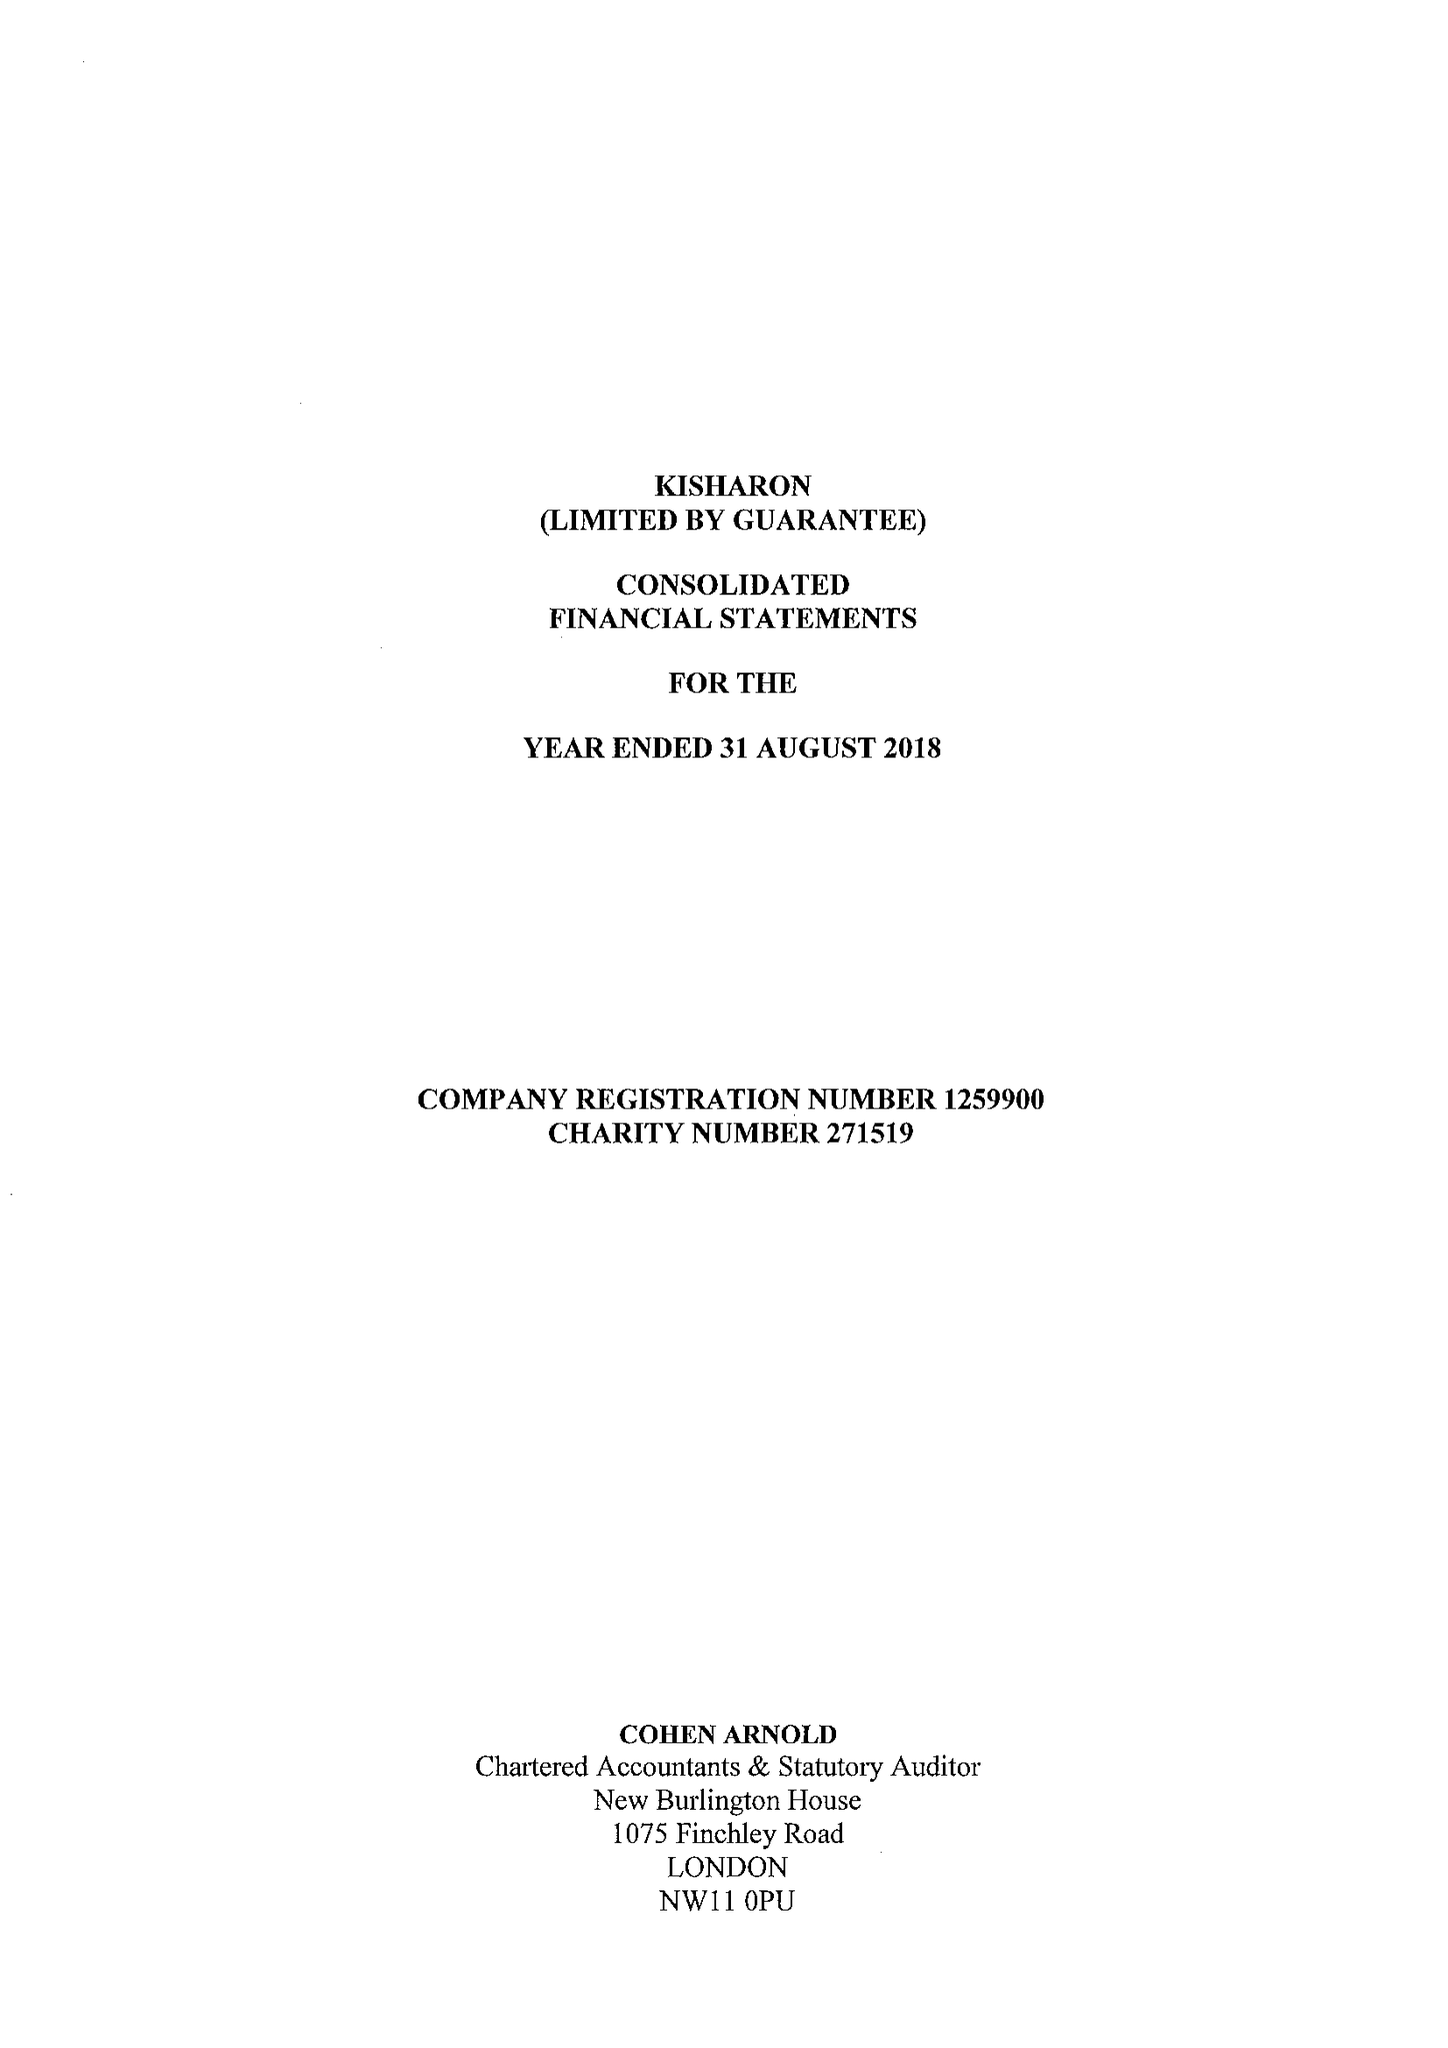What is the value for the report_date?
Answer the question using a single word or phrase. 2018-08-31 